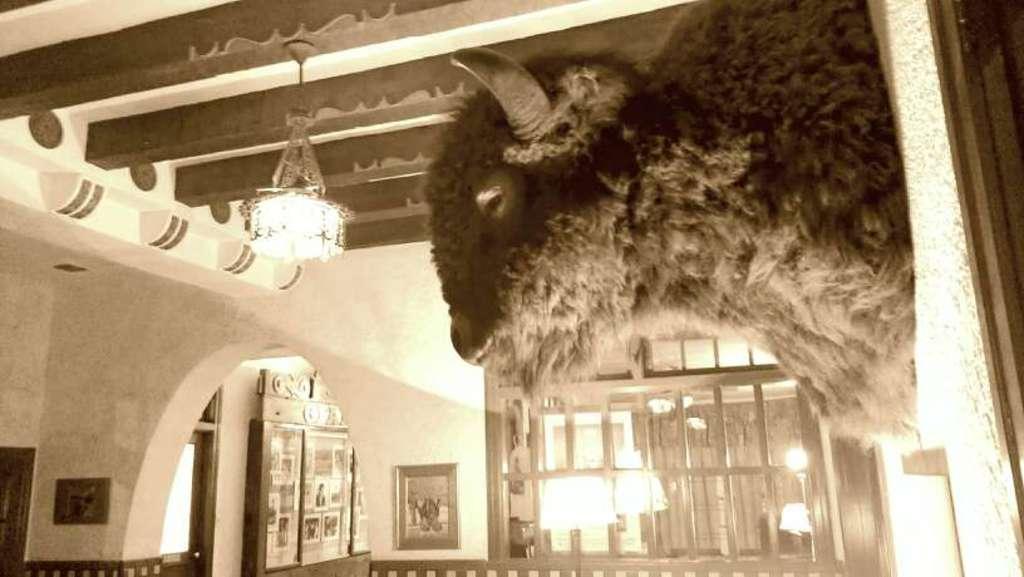Can you describe this image briefly? In this picture we can see a wall mount on the right side, there is a chandelier here, in the background there is a wall, we can see a portrait and some photos pasted on the wall, we can see lights here. 